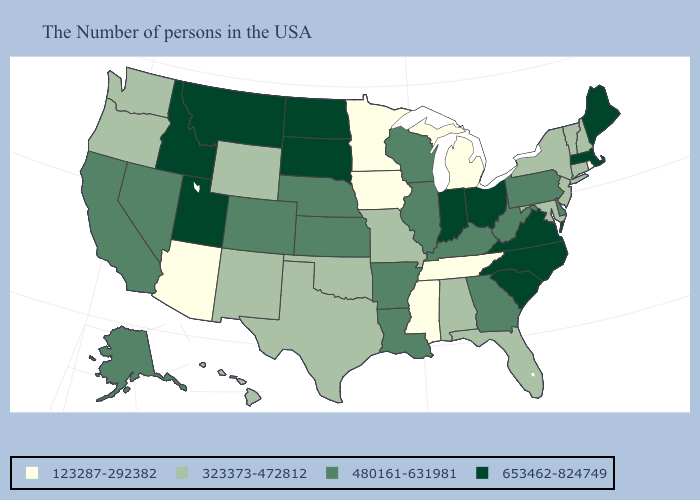How many symbols are there in the legend?
Answer briefly. 4. Which states hav the highest value in the MidWest?
Concise answer only. Ohio, Indiana, South Dakota, North Dakota. Among the states that border Minnesota , does Iowa have the highest value?
Be succinct. No. What is the value of Kansas?
Write a very short answer. 480161-631981. Name the states that have a value in the range 480161-631981?
Concise answer only. Delaware, Pennsylvania, West Virginia, Georgia, Kentucky, Wisconsin, Illinois, Louisiana, Arkansas, Kansas, Nebraska, Colorado, Nevada, California, Alaska. What is the highest value in the USA?
Quick response, please. 653462-824749. What is the highest value in states that border Tennessee?
Write a very short answer. 653462-824749. Which states have the lowest value in the South?
Write a very short answer. Tennessee, Mississippi. Which states have the lowest value in the USA?
Be succinct. Rhode Island, Michigan, Tennessee, Mississippi, Minnesota, Iowa, Arizona. Is the legend a continuous bar?
Write a very short answer. No. What is the lowest value in the Northeast?
Quick response, please. 123287-292382. Name the states that have a value in the range 123287-292382?
Give a very brief answer. Rhode Island, Michigan, Tennessee, Mississippi, Minnesota, Iowa, Arizona. Name the states that have a value in the range 653462-824749?
Be succinct. Maine, Massachusetts, Virginia, North Carolina, South Carolina, Ohio, Indiana, South Dakota, North Dakota, Utah, Montana, Idaho. What is the value of Indiana?
Answer briefly. 653462-824749. Among the states that border South Carolina , does North Carolina have the lowest value?
Keep it brief. No. 